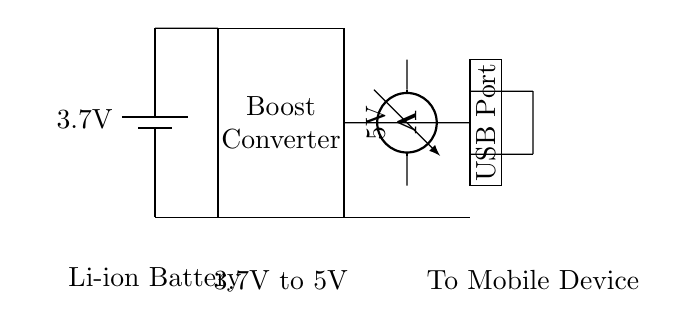What is the voltage of the battery? The voltage label on the battery indicates a value of 3.7V. This is directly stated in the circuit diagram.
Answer: 3.7V What component is responsible for increasing the voltage? The boost converter is the component designed to step up the voltage from 3.7V to a higher level for USB charging. This is indicated by the label next to the rectangle representing the boost converter.
Answer: Boost Converter What is the output voltage after the boost converter? The voltmeter indicates that the output voltage after the boost converter is 5V. This shows the conversion from the input battery voltage to the standard USB output voltage.
Answer: 5V How many connections are there from the battery to the USB port? There are three direct connections shown in the circuit: one from the positive terminal of the battery to the boost converter, one from the boost converter to the USB port, and one from the negative terminal of the battery to the ground via the USB port.
Answer: Three What type of battery is used in the circuit? The circuit specifies that a lithium-ion battery is used, indicated by the label on the battery component.
Answer: Li-ion Battery What function does the USB port serve in this circuit? The USB port functions as the output interface to connect mobile devices for charging, allowing the 5V output from the boost converter to power them. This function is indicated by the label associated with the USB port.
Answer: Charging Interface 